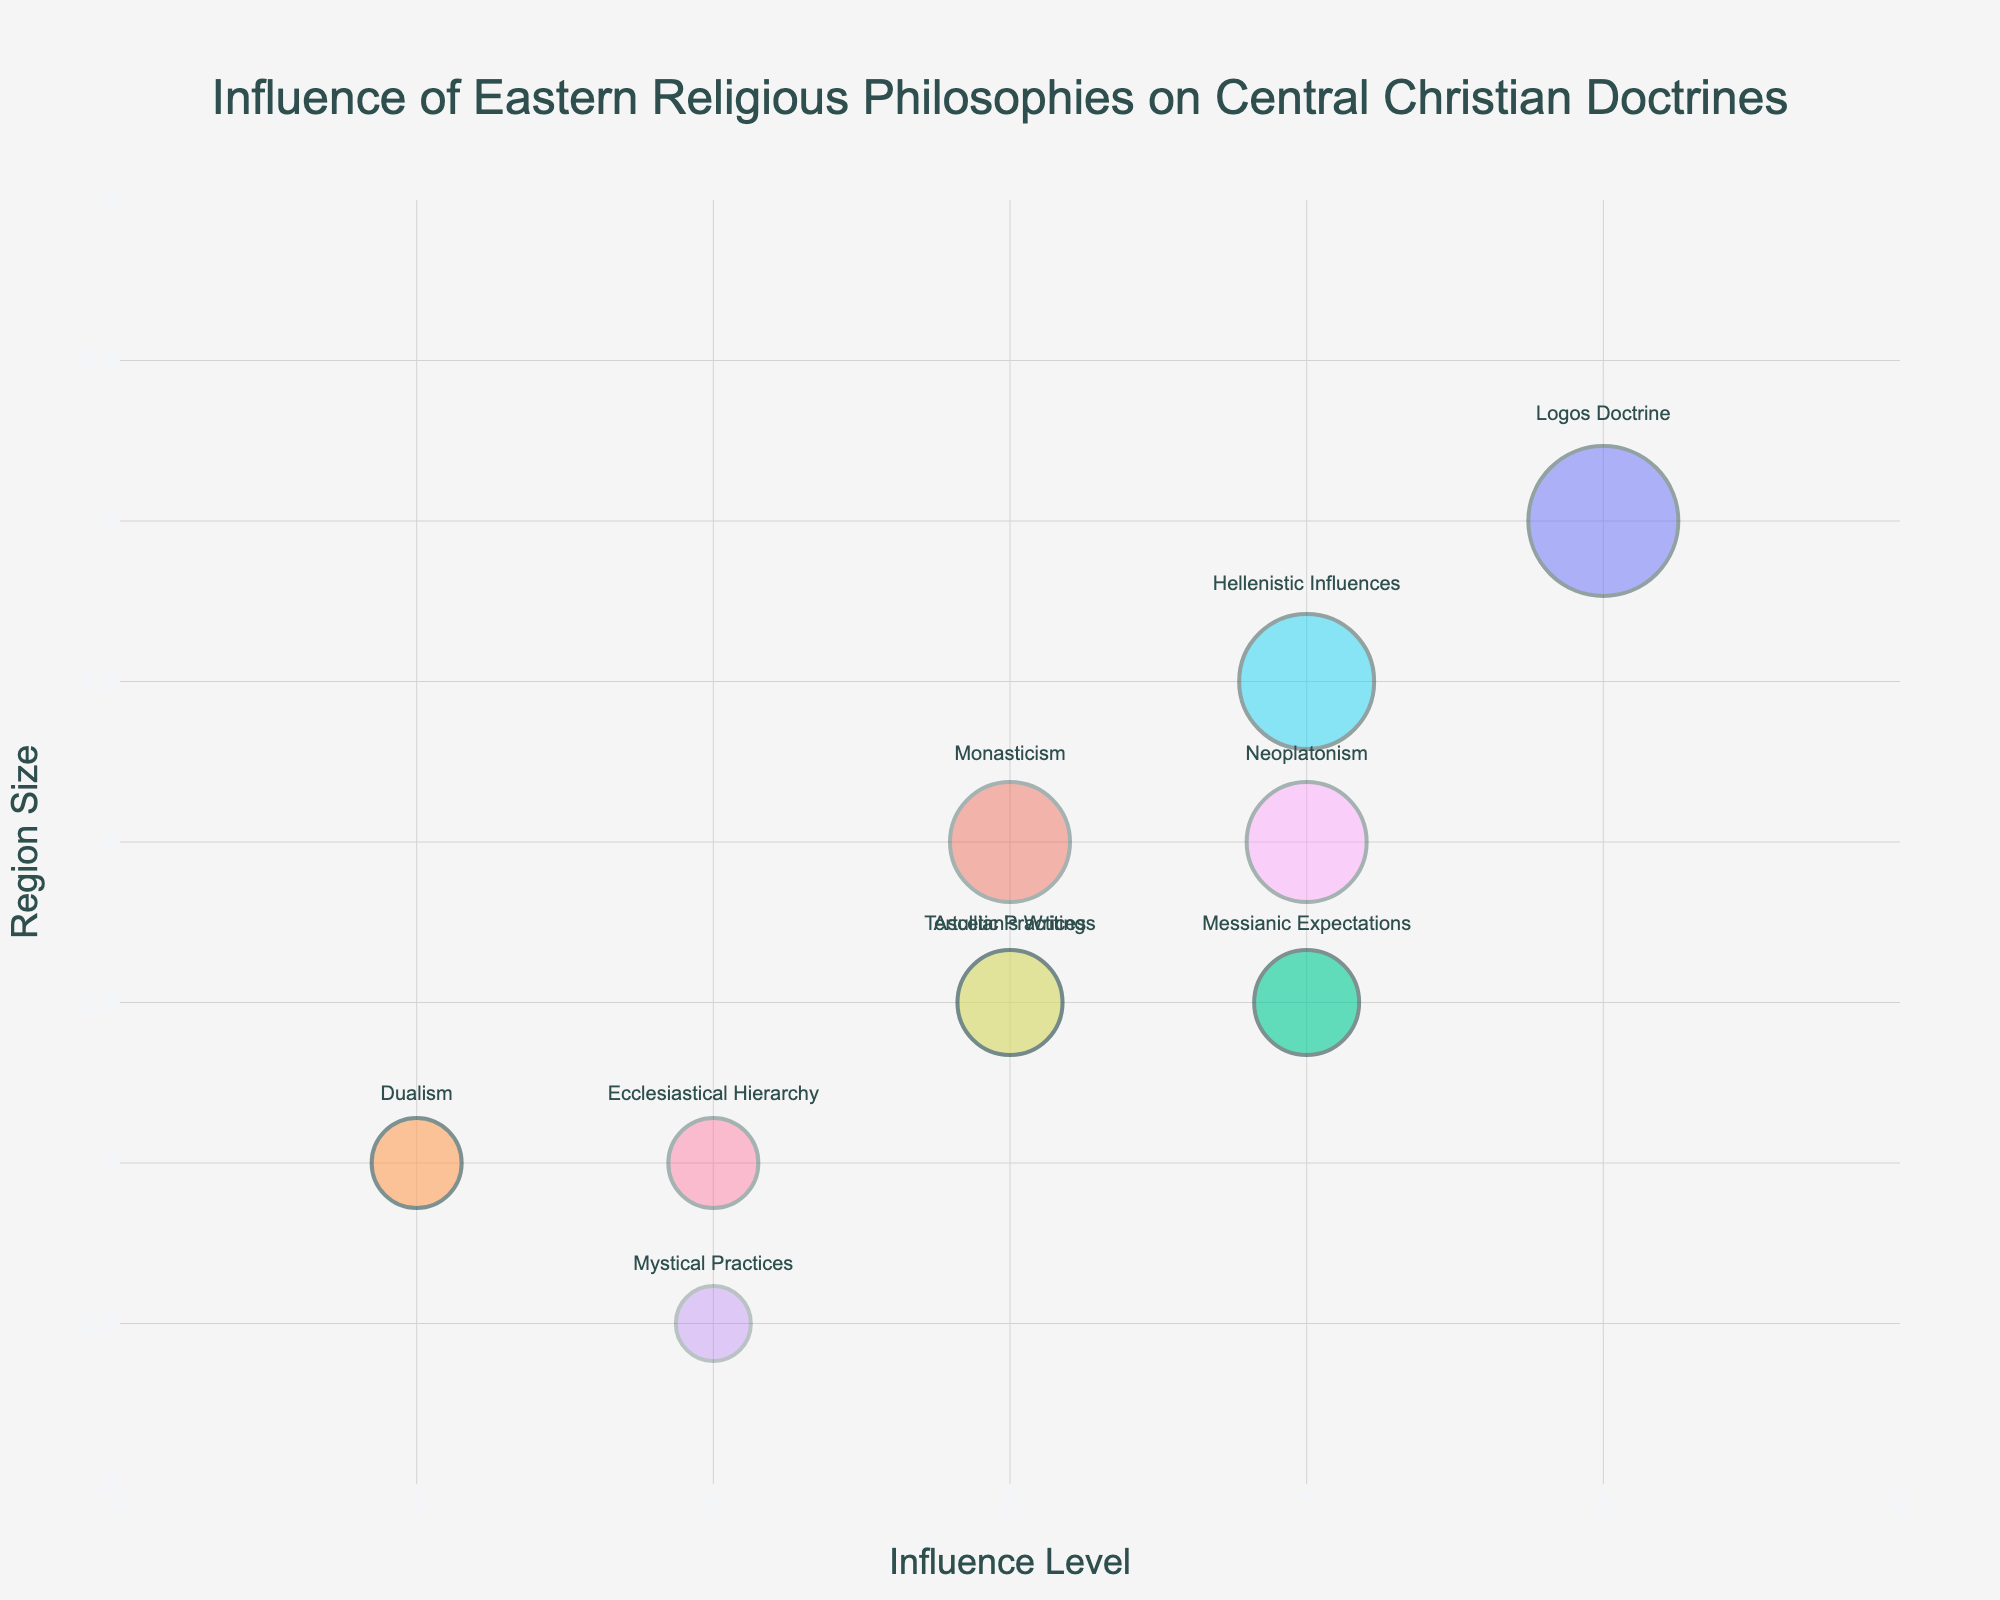What is the title of the figure? The title of the figure is displayed at the top center of the plot. It reads "Influence of Eastern Religious Philosophies on Central Christian Doctrines."
Answer: Influence of Eastern Religious Philosophies on Central Christian Doctrines What are the axes representing in the figure? The x-axis represents the "Influence Level" and the y-axis represents the "Region Size" as shown by the axis titles.
Answer: Influence Level (x-axis) and Region Size (y-axis) How many data points are shown in the figure? By counting the unique bubbles on the plot, we can see there are 10 data points corresponding to the 10 regions listed in the dataset.
Answer: 10 Which region has the highest influence level and what doctrine is it associated with? By observing the x-axis and identifying the region with the highest value, Asia Minor has the highest influence level of 8, associated with the Logos Doctrine.
Answer: Asia Minor, Logos Doctrine Which doctrine is associated with the region that has the largest size bubble? By observing the size of the bubbles, the largest bubble corresponds to the value 5 in Region Size, which is associated with Asia Minor. The doctrine is the Logos Doctrine.
Answer: Logos Doctrine Which regions have an influence level of 7? By observing the x-axis for the value 7 and checking associated regions, the regions with an influence level of 7 are Israel, Greece, and Alexandria.
Answer: Israel, Greece, Alexandria What is the average translucency of all the bubbles? To find the average translucency, sum all values in the translucency column and divide by the number of data points: (0.5 + 0.4 + 0.6 + 0.3 + 0.6 + 0.5 + 0.4 + 0.5 + 0.4 + 0.3)/10 = 4.5/10 = 0.45.
Answer: 0.45 Which region has a higher influence level, Greece or Syria? By comparing the x-axis values, both Greece and Syria have a value of 7 for Greece and 6 for Syria. So, Greece has a higher influence level.
Answer: Greece What is the difference in influence level between the regions associated with Dualism and Mystical Practices? Identifying the influence levels of Persia (Dualism) as 4 and India (Mystical Practices) as 5. The difference is 5 - 4 = 1.
Answer: 1 Which region’s bubble is the most translucent, and what is its influence level? By observing the opacity of the bubbles, the region with the lowest translucency value (highest transparency) is India with a translucency of 0.3. Its influence level is 5.
Answer: India, 5 